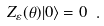<formula> <loc_0><loc_0><loc_500><loc_500>Z _ { \varepsilon } ( \theta ) | 0 \rangle = 0 \ .</formula> 